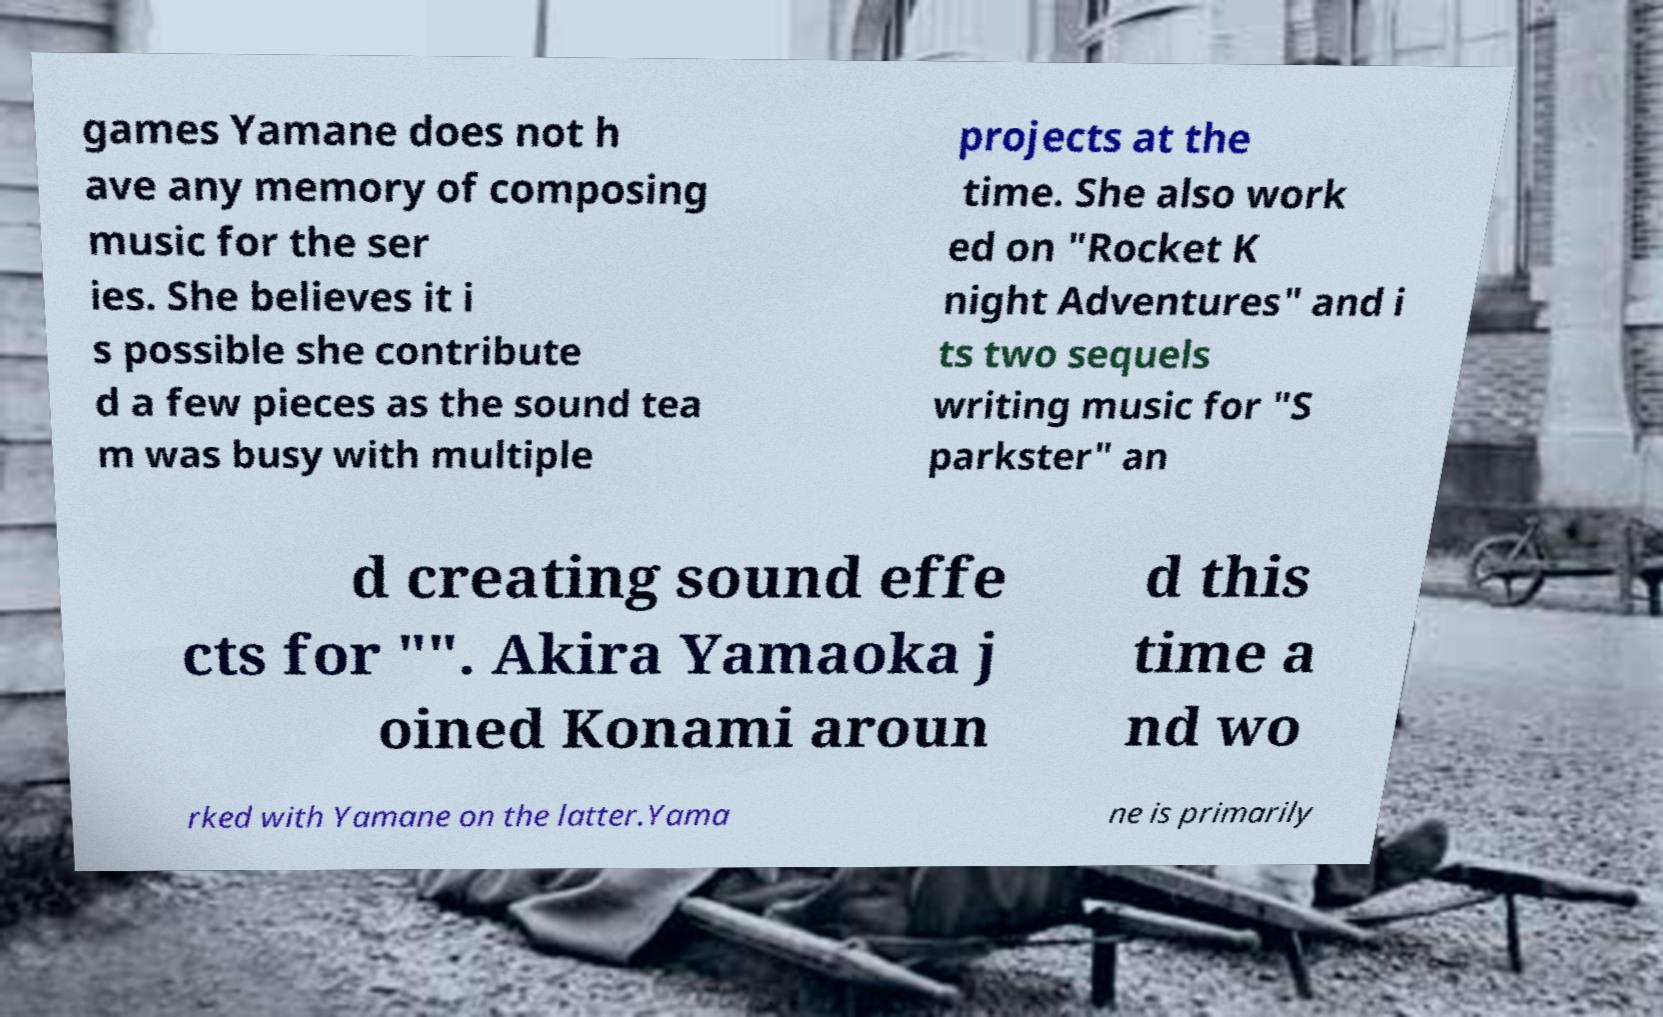Can you accurately transcribe the text from the provided image for me? games Yamane does not h ave any memory of composing music for the ser ies. She believes it i s possible she contribute d a few pieces as the sound tea m was busy with multiple projects at the time. She also work ed on "Rocket K night Adventures" and i ts two sequels writing music for "S parkster" an d creating sound effe cts for "". Akira Yamaoka j oined Konami aroun d this time a nd wo rked with Yamane on the latter.Yama ne is primarily 